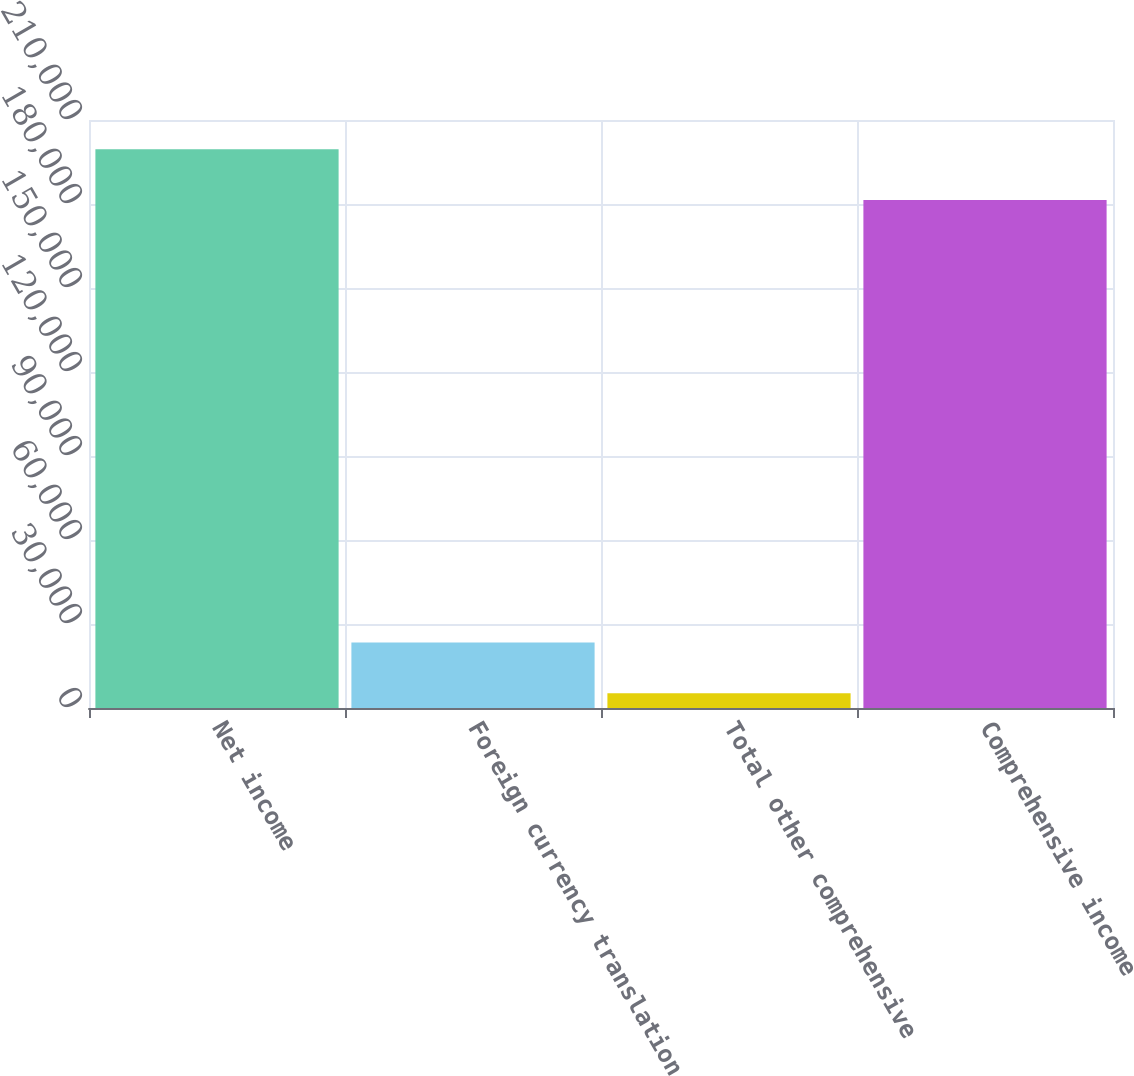Convert chart to OTSL. <chart><loc_0><loc_0><loc_500><loc_500><bar_chart><fcel>Net income<fcel>Foreign currency translation<fcel>Total other comprehensive<fcel>Comprehensive income<nl><fcel>199563<fcel>23399.1<fcel>5257<fcel>181421<nl></chart> 